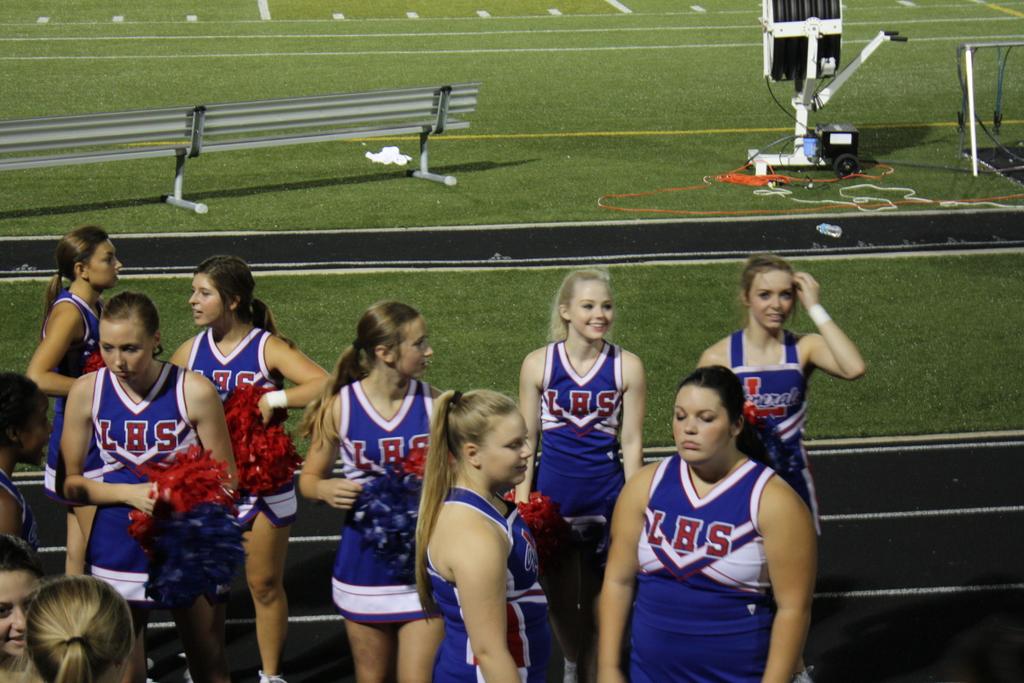Which team is this?
Keep it short and to the point. Lhs. What high schools are the cheerleaders from?
Your answer should be compact. Lbs. 